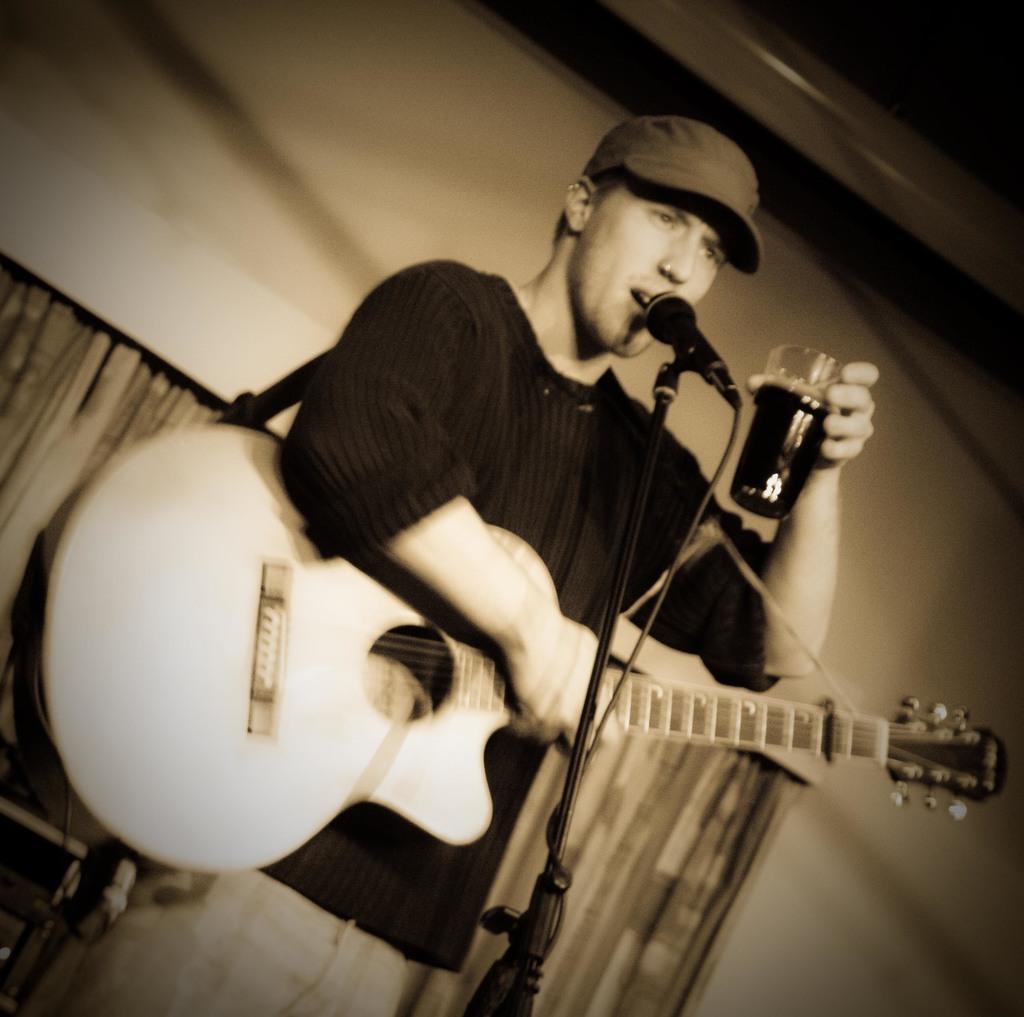How would you summarize this image in a sentence or two? In this picture there is a man holding a guitar and a glass in his hands. There is a mic. There is a curtain at the background. 